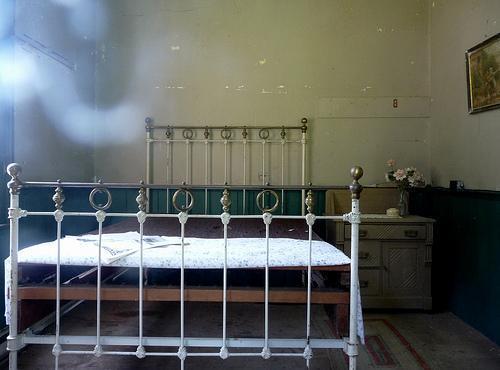How many beds are there?
Give a very brief answer. 1. 